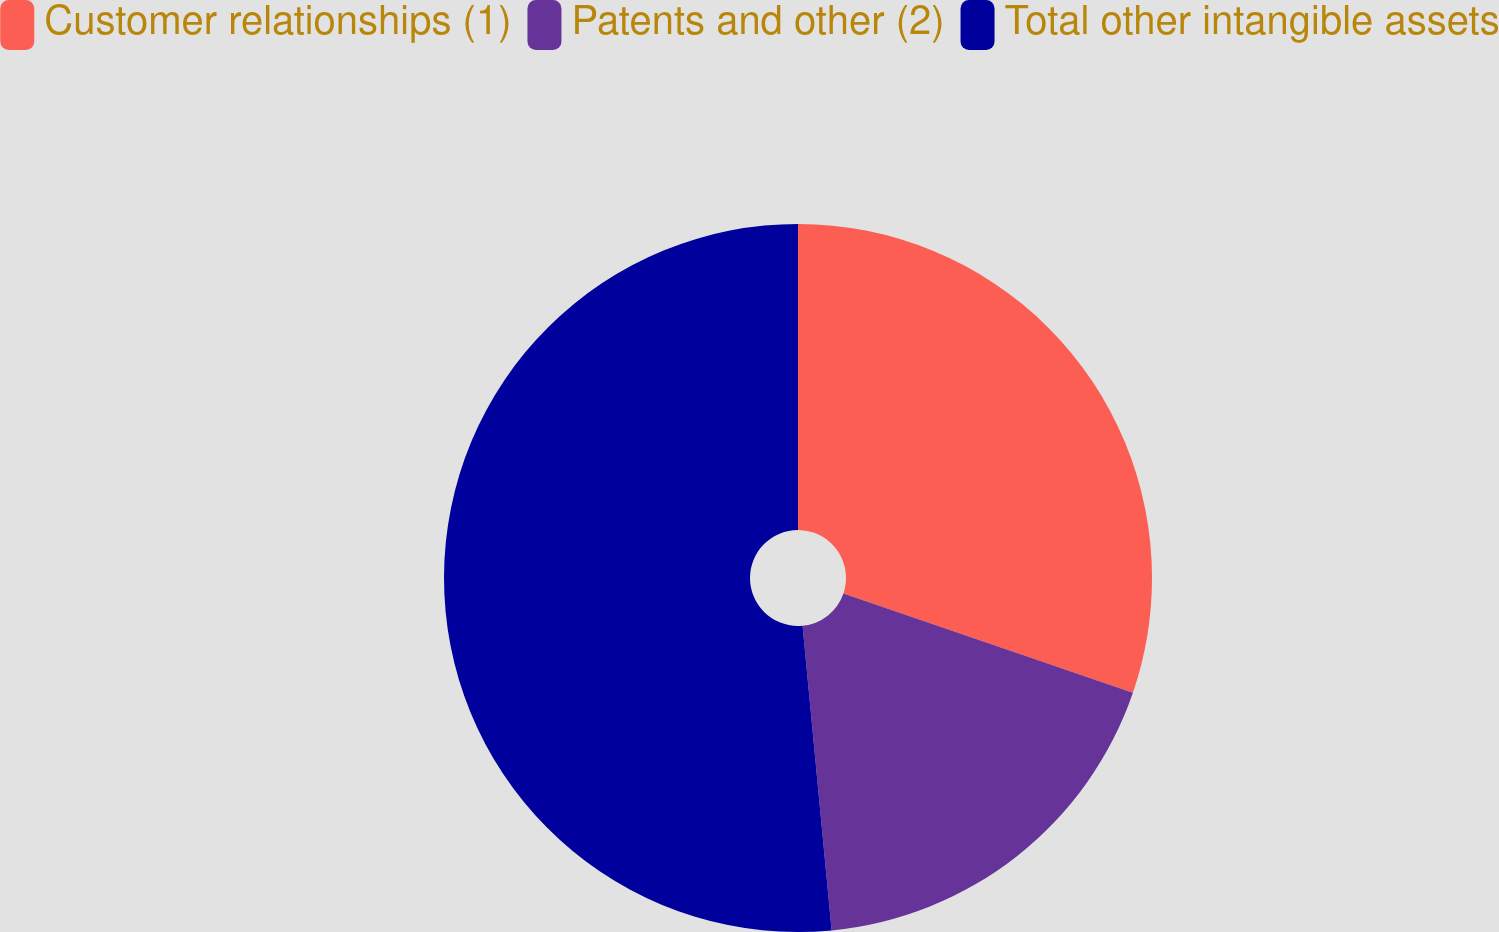Convert chart. <chart><loc_0><loc_0><loc_500><loc_500><pie_chart><fcel>Customer relationships (1)<fcel>Patents and other (2)<fcel>Total other intangible assets<nl><fcel>30.25%<fcel>18.23%<fcel>51.51%<nl></chart> 